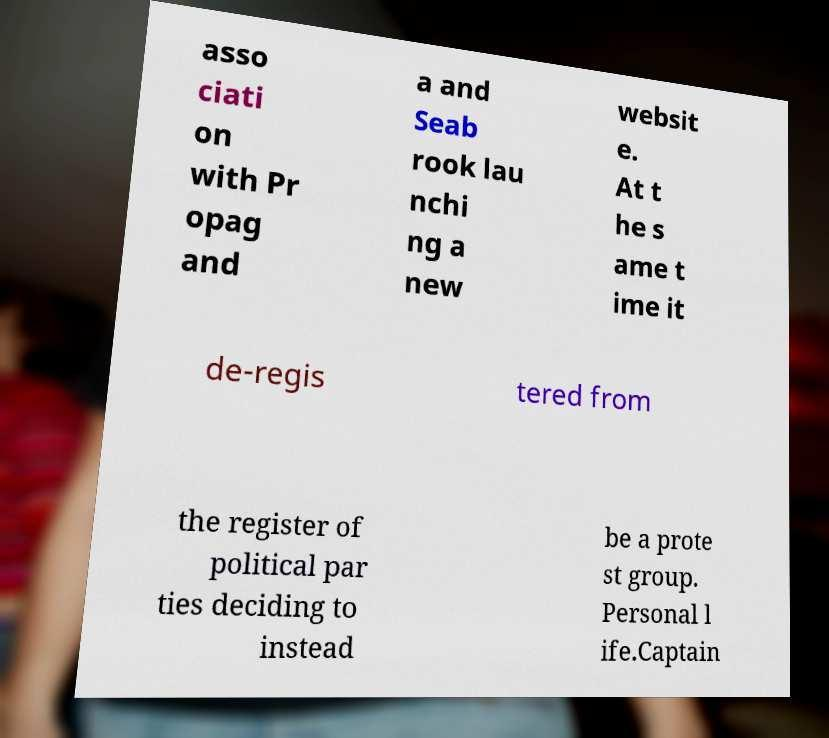Could you assist in decoding the text presented in this image and type it out clearly? asso ciati on with Pr opag and a and Seab rook lau nchi ng a new websit e. At t he s ame t ime it de-regis tered from the register of political par ties deciding to instead be a prote st group. Personal l ife.Captain 